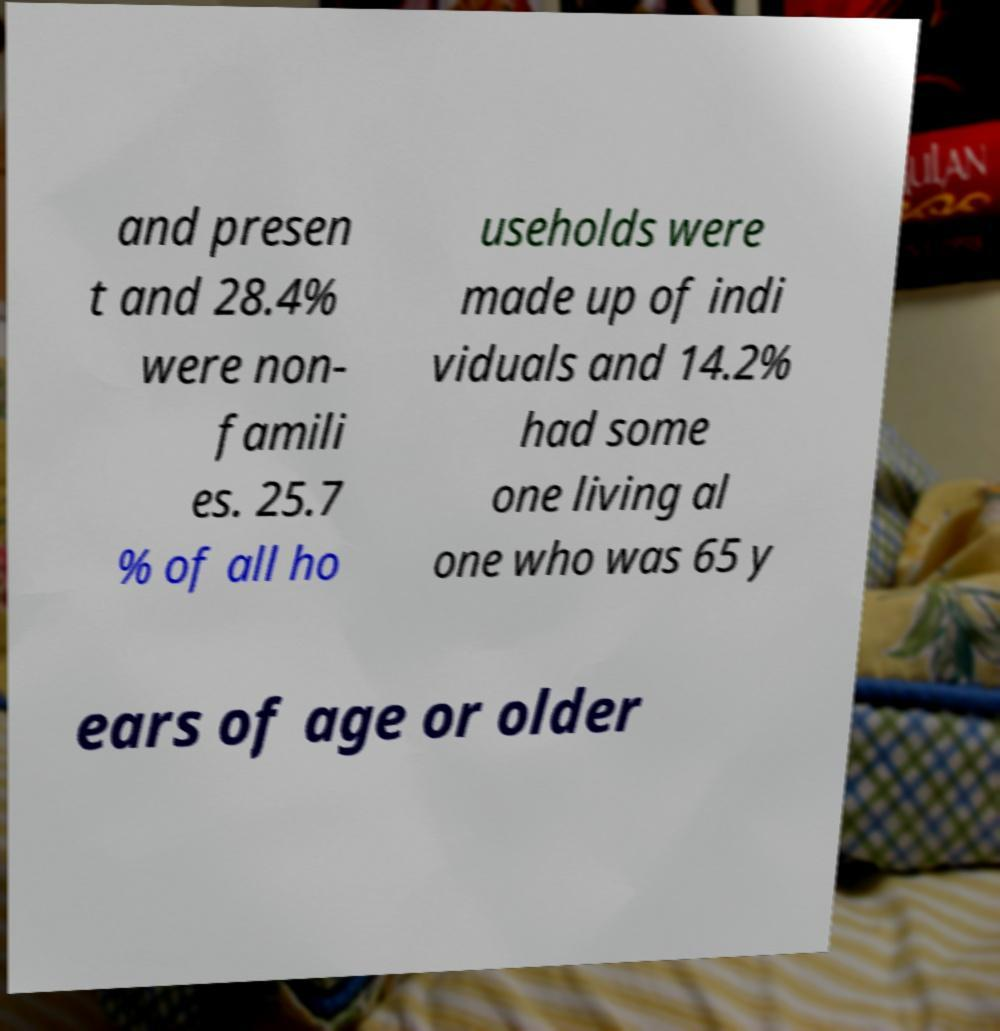Could you assist in decoding the text presented in this image and type it out clearly? and presen t and 28.4% were non- famili es. 25.7 % of all ho useholds were made up of indi viduals and 14.2% had some one living al one who was 65 y ears of age or older 